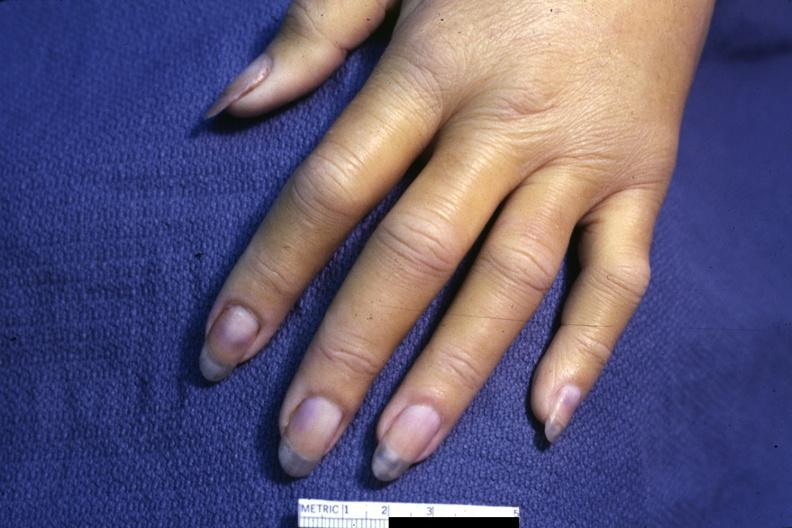does metastatic carcinoma lung show case of dic not bad photo requires dark room to see subtle distal phalangeal cyanosis?
Answer the question using a single word or phrase. No 